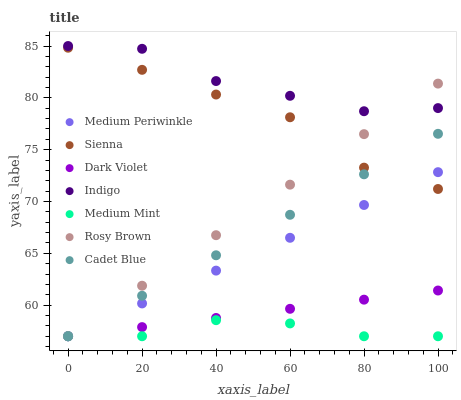Does Medium Mint have the minimum area under the curve?
Answer yes or no. Yes. Does Indigo have the maximum area under the curve?
Answer yes or no. Yes. Does Cadet Blue have the minimum area under the curve?
Answer yes or no. No. Does Cadet Blue have the maximum area under the curve?
Answer yes or no. No. Is Cadet Blue the smoothest?
Answer yes or no. Yes. Is Indigo the roughest?
Answer yes or no. Yes. Is Indigo the smoothest?
Answer yes or no. No. Is Cadet Blue the roughest?
Answer yes or no. No. Does Medium Mint have the lowest value?
Answer yes or no. Yes. Does Indigo have the lowest value?
Answer yes or no. No. Does Indigo have the highest value?
Answer yes or no. Yes. Does Cadet Blue have the highest value?
Answer yes or no. No. Is Medium Mint less than Sienna?
Answer yes or no. Yes. Is Indigo greater than Medium Periwinkle?
Answer yes or no. Yes. Does Medium Periwinkle intersect Cadet Blue?
Answer yes or no. Yes. Is Medium Periwinkle less than Cadet Blue?
Answer yes or no. No. Is Medium Periwinkle greater than Cadet Blue?
Answer yes or no. No. Does Medium Mint intersect Sienna?
Answer yes or no. No. 